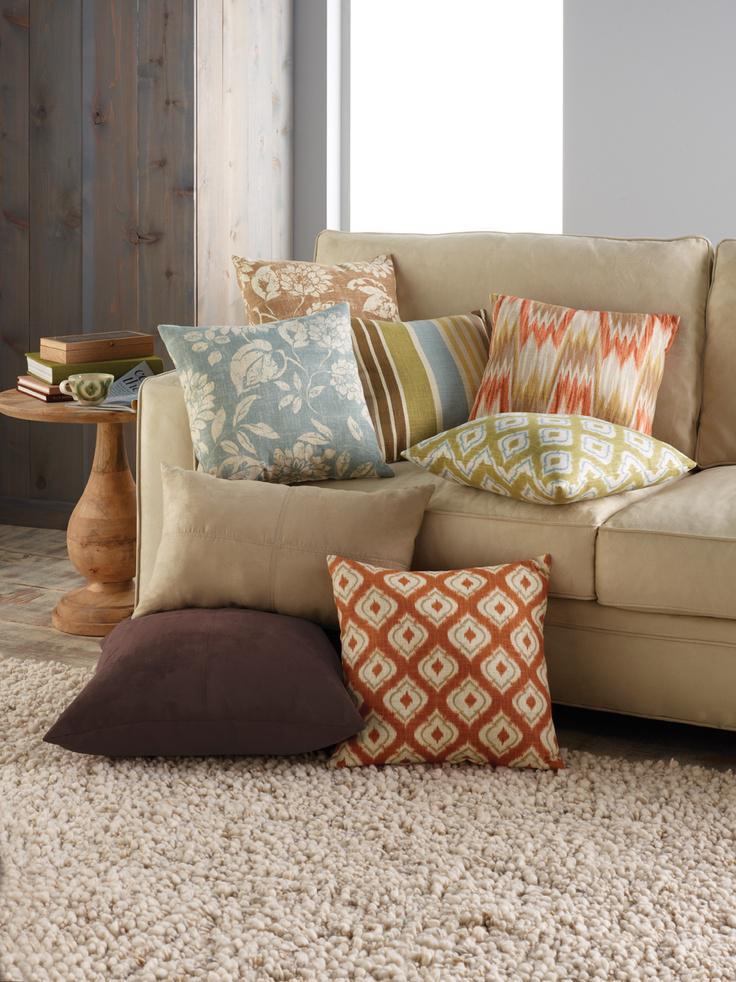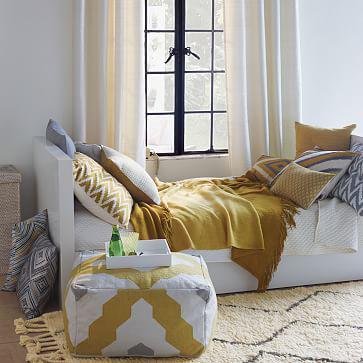The first image is the image on the left, the second image is the image on the right. Analyze the images presented: Is the assertion "There is a plant on the coffee table in at least one image." valid? Answer yes or no. No. The first image is the image on the left, the second image is the image on the right. Examine the images to the left and right. Is the description "In one image, a bottle and glass containing a drink are sitting near a seating area." accurate? Answer yes or no. Yes. 